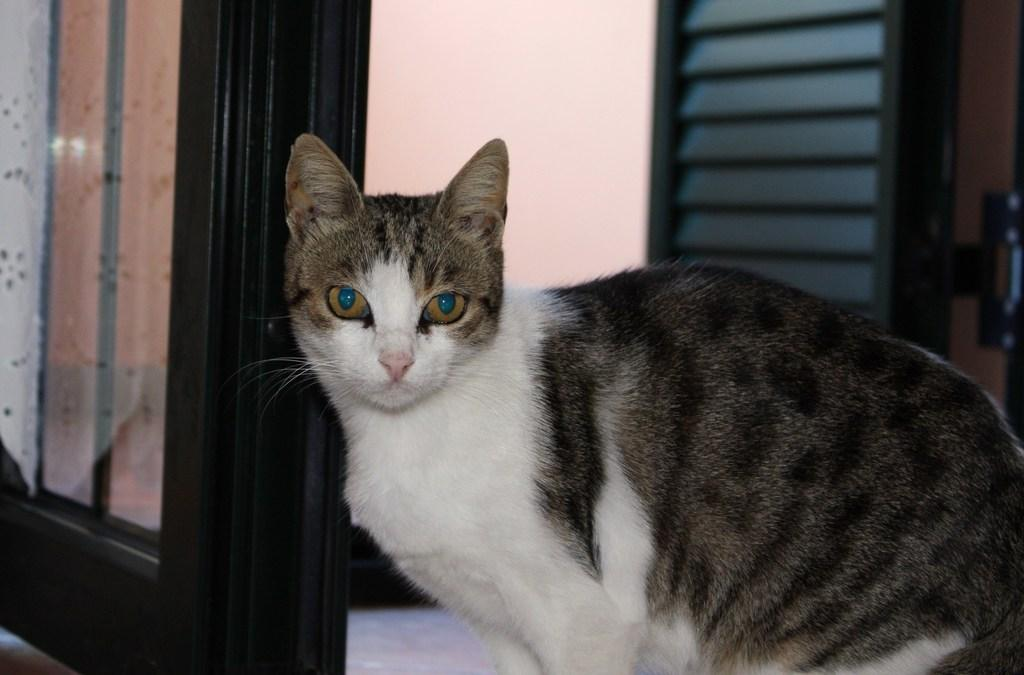What type of animal is in the image? There is a cat in the image. What can be seen in the background of the image? There is a door and a wall visible in the background of the image. What type of baseball equipment can be seen in the image? There is no baseball equipment present in the image; it features a cat and a background with a door and a wall. 